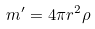Convert formula to latex. <formula><loc_0><loc_0><loc_500><loc_500>m ^ { \prime } = 4 \pi r ^ { 2 } \rho</formula> 